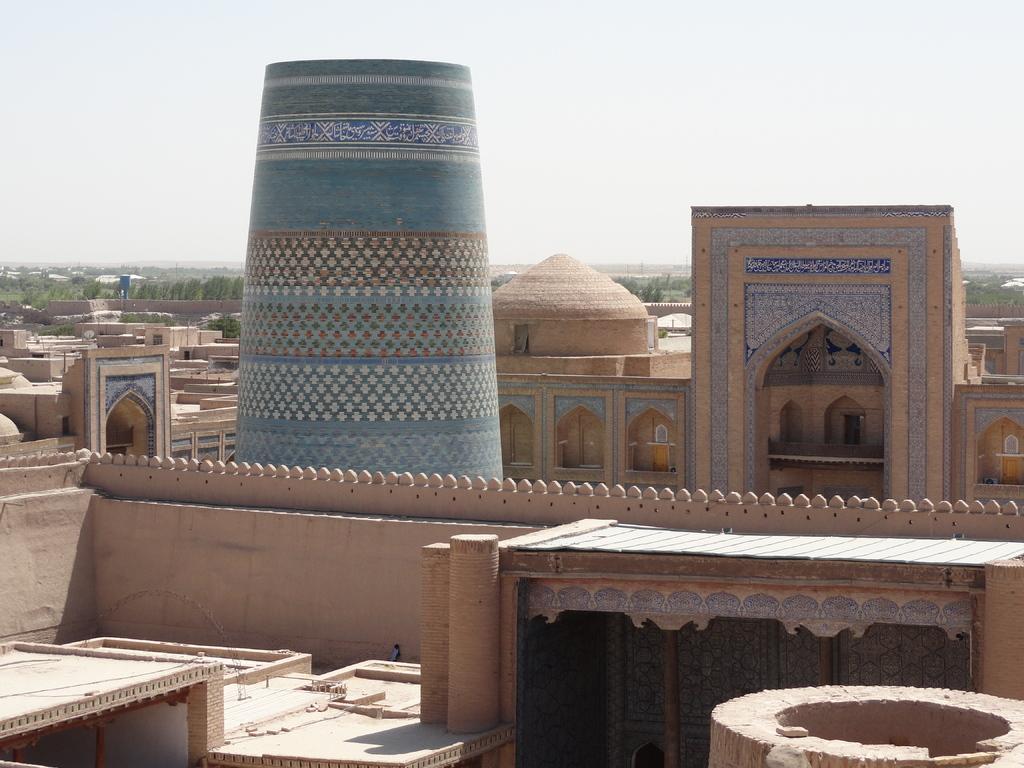In one or two sentences, can you explain what this image depicts? In this picture, it seems to be a building in the image and there are arches in the image, there are houses in the image and there are trees in the background area of the image. 